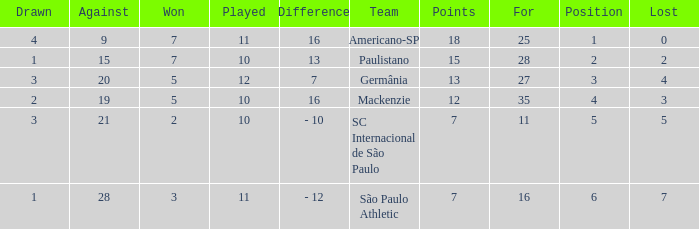Name the least for when played is 12 27.0. 